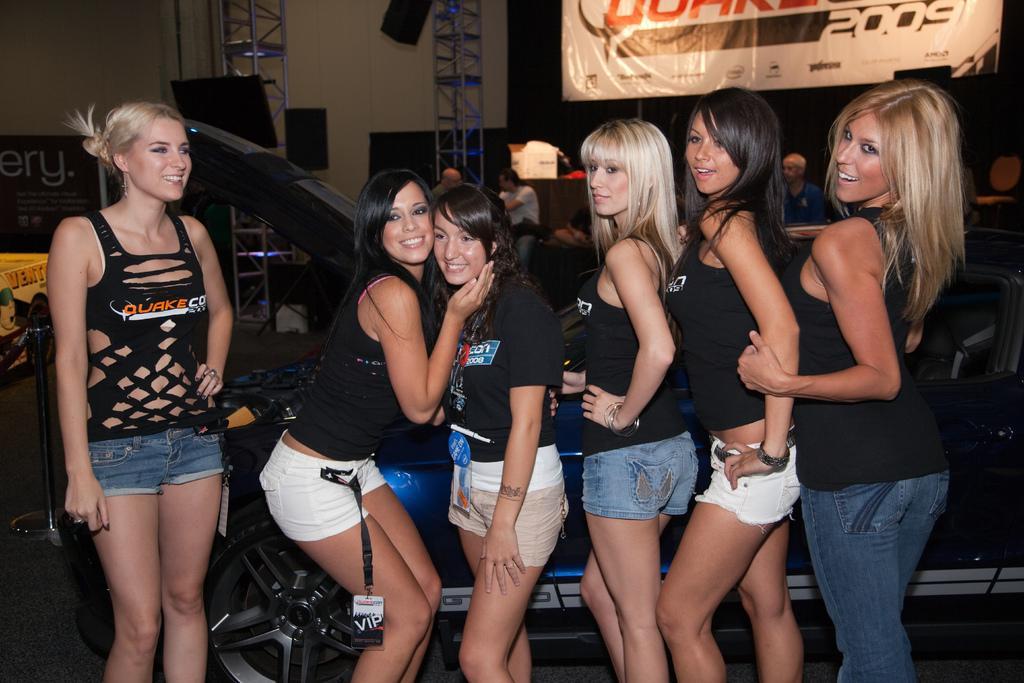In one or two sentences, can you explain what this image depicts? In the foreground of the picture there are women standing, beside a car. In the background there are banner, iron frames, people and other objects. On the left there is a stand. 